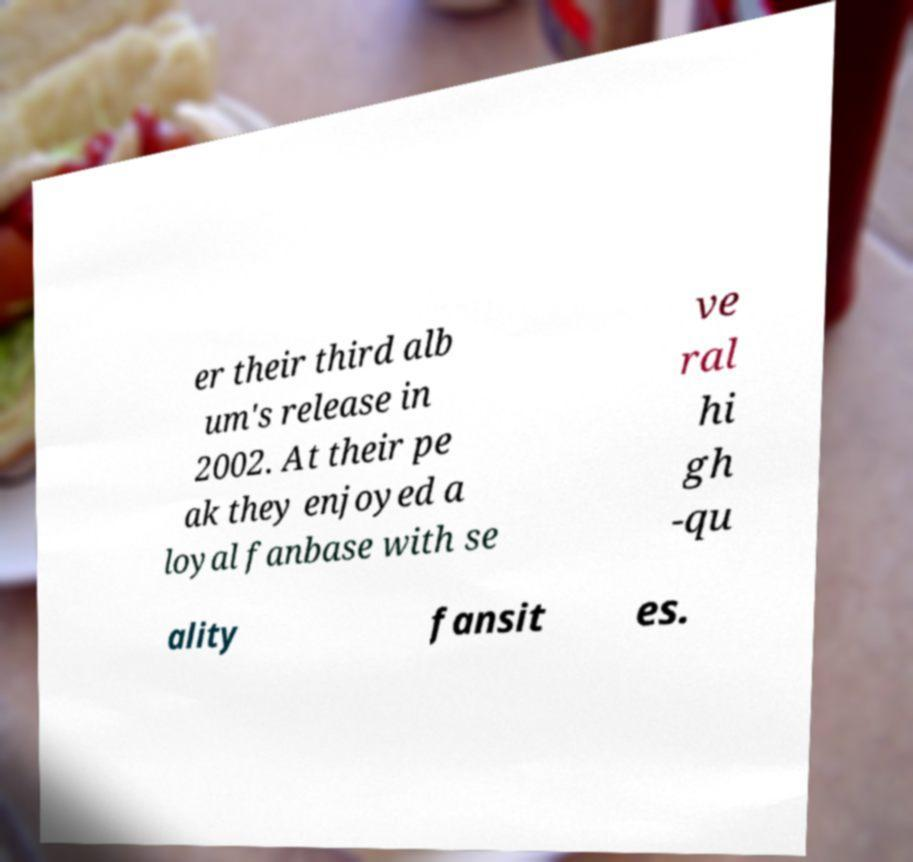For documentation purposes, I need the text within this image transcribed. Could you provide that? er their third alb um's release in 2002. At their pe ak they enjoyed a loyal fanbase with se ve ral hi gh -qu ality fansit es. 